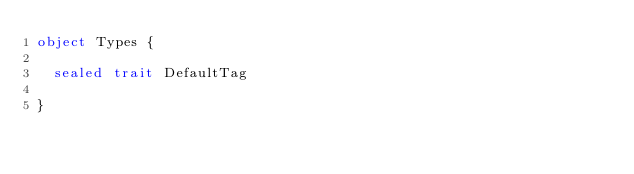<code> <loc_0><loc_0><loc_500><loc_500><_Scala_>object Types {

  sealed trait DefaultTag

}
</code> 